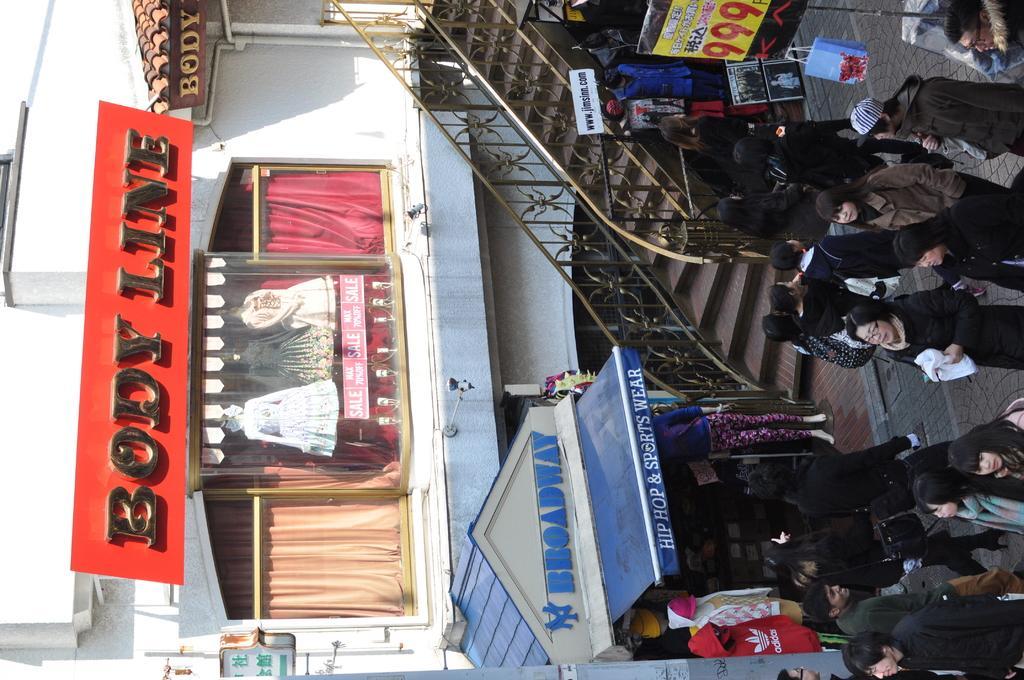In one or two sentences, can you explain what this image depicts? This picture is of outside. In the center there are group of persons seems to be walking. On the right there is a board to which a bag is hanging. In the center there is a staircase and a tent with a mannequin and in the background there is a board, window, mannequins and the building. 